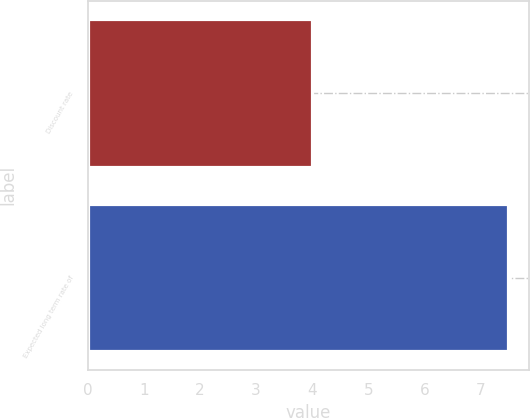Convert chart. <chart><loc_0><loc_0><loc_500><loc_500><bar_chart><fcel>Discount rate<fcel>Expected long term rate of<nl><fcel>4<fcel>7.5<nl></chart> 